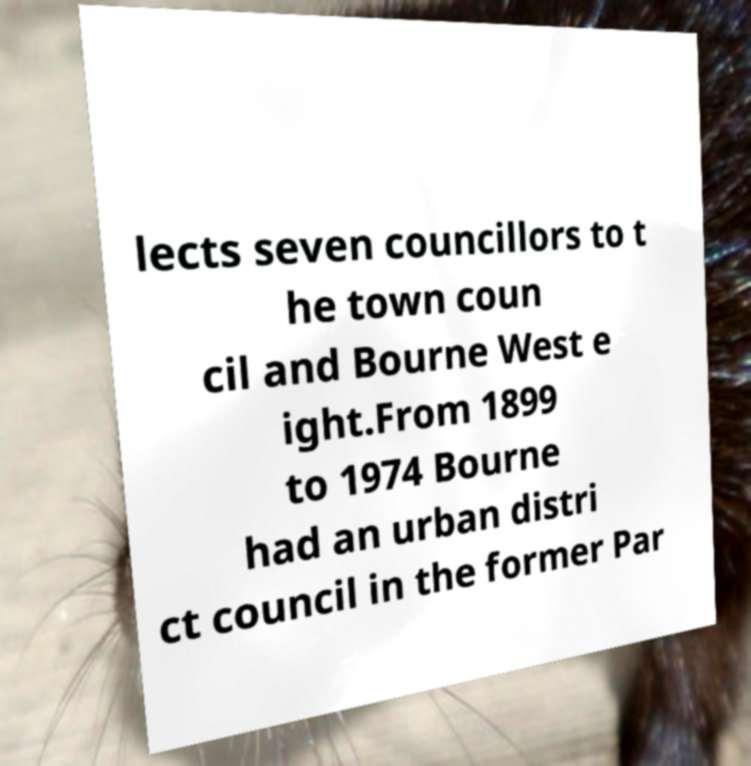Could you extract and type out the text from this image? lects seven councillors to t he town coun cil and Bourne West e ight.From 1899 to 1974 Bourne had an urban distri ct council in the former Par 